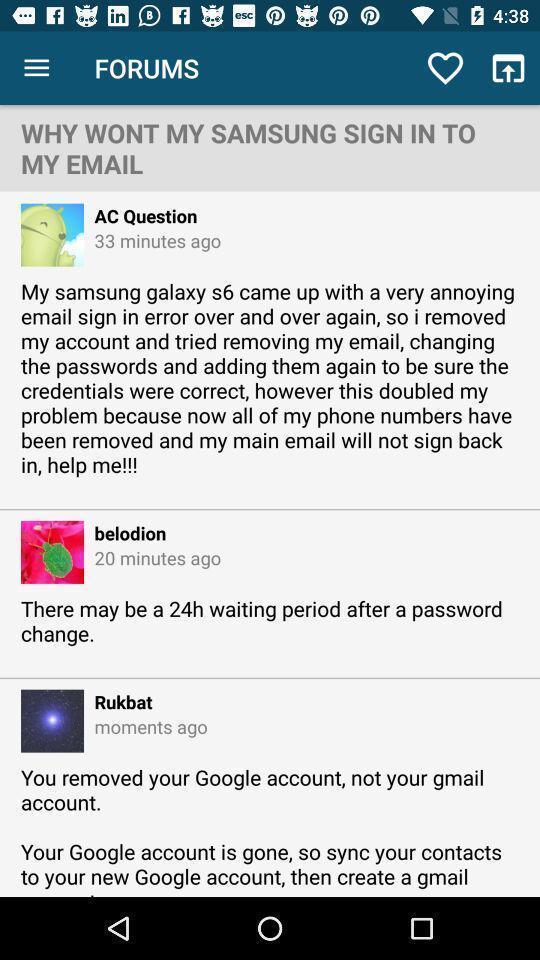What details can you identify in this image? Sign in page for forum. 